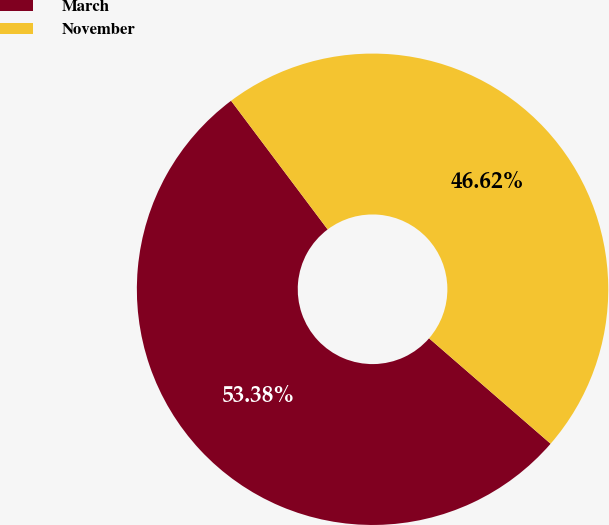<chart> <loc_0><loc_0><loc_500><loc_500><pie_chart><fcel>March<fcel>November<nl><fcel>53.38%<fcel>46.62%<nl></chart> 